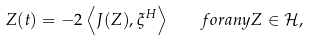Convert formula to latex. <formula><loc_0><loc_0><loc_500><loc_500>Z ( t ) = - 2 \left \langle J ( Z ) , \xi ^ { H } \right \rangle \quad f o r a n y Z \in \mathcal { H } ,</formula> 